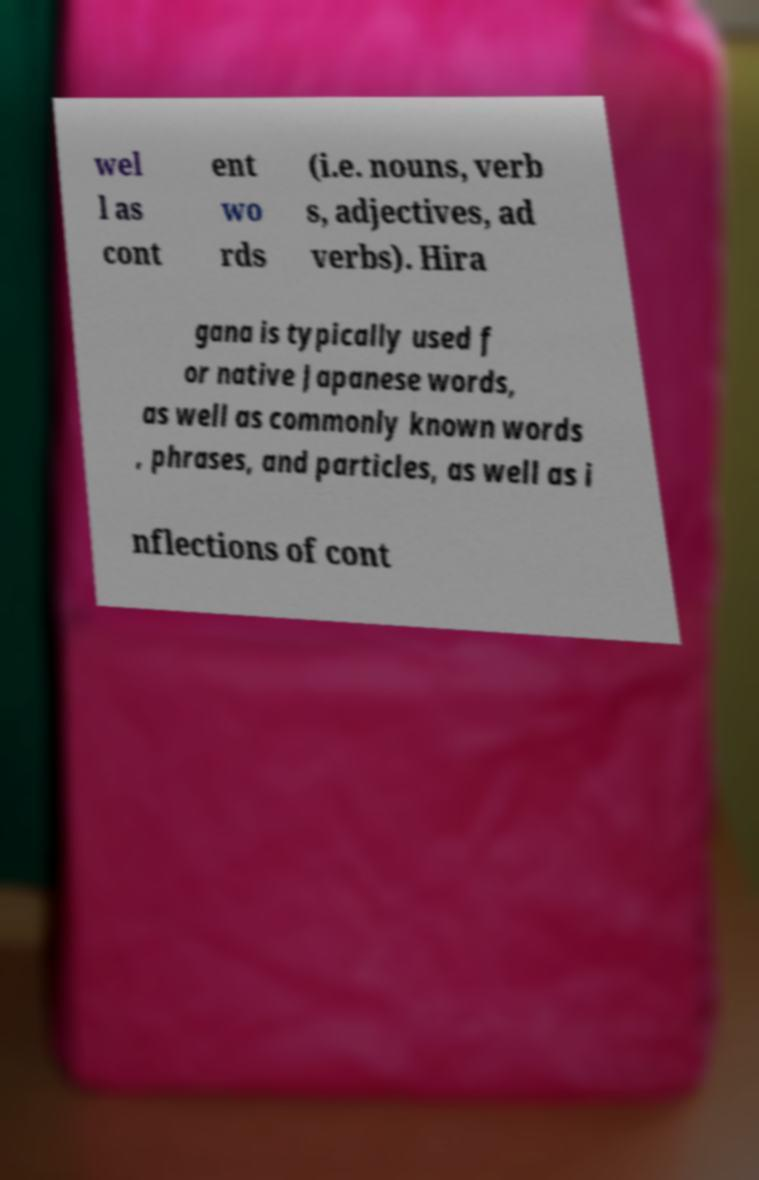There's text embedded in this image that I need extracted. Can you transcribe it verbatim? wel l as cont ent wo rds (i.e. nouns, verb s, adjectives, ad verbs). Hira gana is typically used f or native Japanese words, as well as commonly known words , phrases, and particles, as well as i nflections of cont 